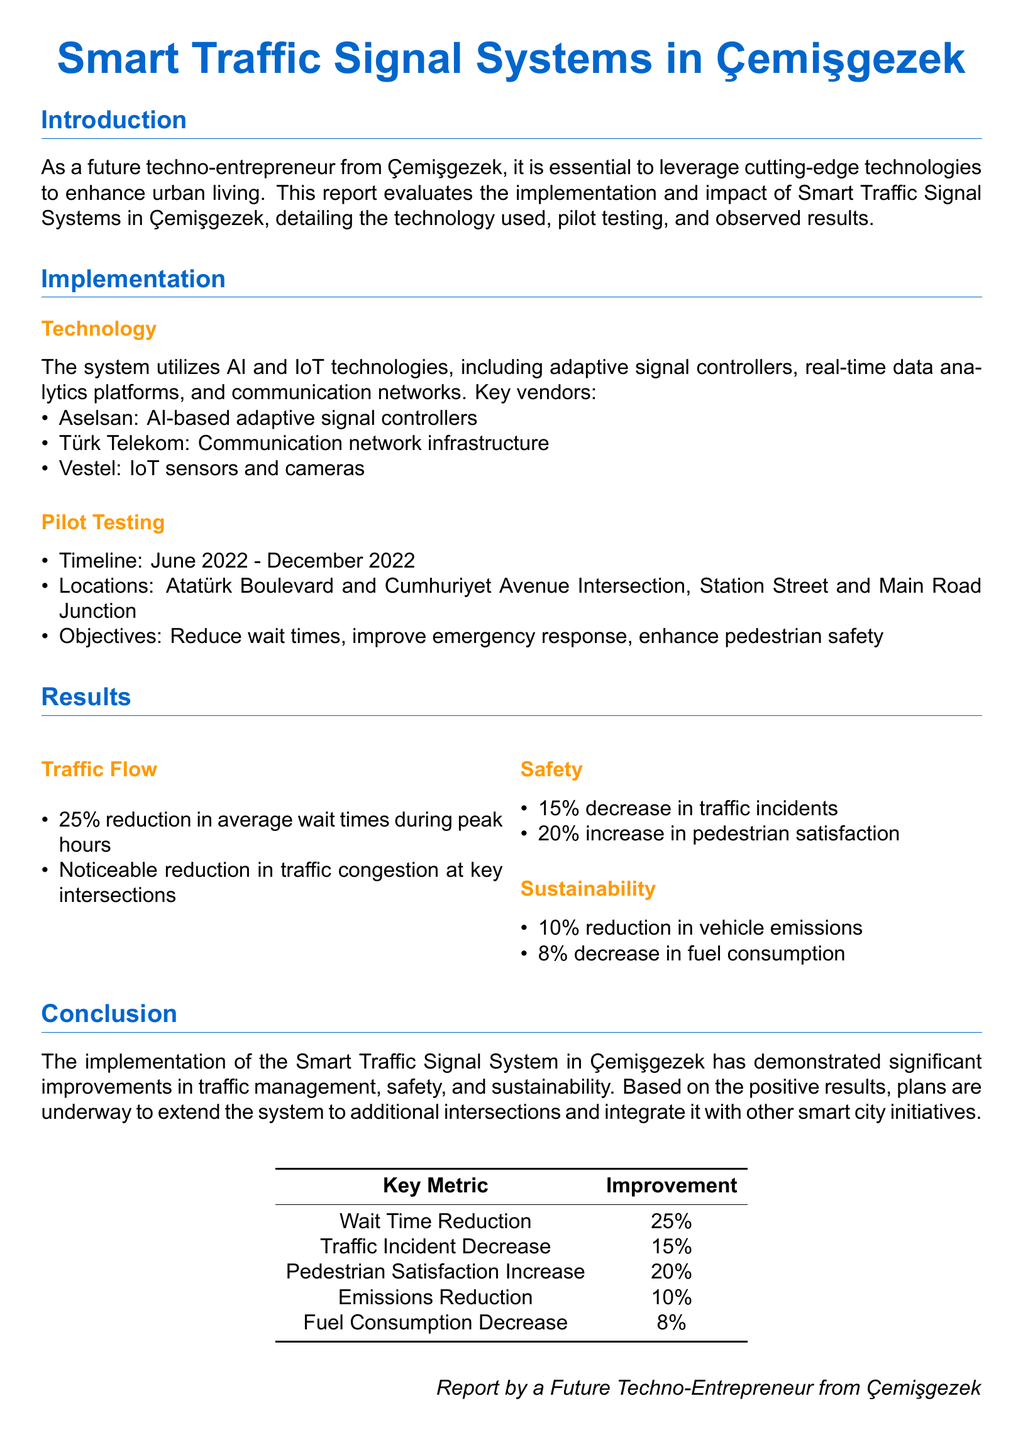What technology is used in the system? The technology used includes AI and IoT, adaptive signal controllers, real-time data analytics, and communication networks.
Answer: AI and IoT technologies What was the timeline for pilot testing? The timeline for pilot testing is explicitly stated in the document.
Answer: June 2022 - December 2022 What percentage reduction in average wait times was observed? The document specifies the percentage reduction in wait times during peak hours.
Answer: 25% How much did traffic incidents decrease by? The report provides a clear metric regarding the change in traffic incidents after implementation.
Answer: 15% Which vendor provided IoT sensors and cameras? The document lists the key vendors and their roles in the project.
Answer: Vestel What was the increase in pedestrian satisfaction? The report quantifies the increase in pedestrian satisfaction following system implementation.
Answer: 20% What is one objective of the Smart Traffic Signal System? The document outlines several objectives for implementing the system.
Answer: Improve emergency response How many key intersections are mentioned for the pilot testing? The specific number of locations for pilot testing is given in the document.
Answer: 2 What is the reported reduction in vehicle emissions? The report details the impact of the system on vehicle emissions.
Answer: 10% 